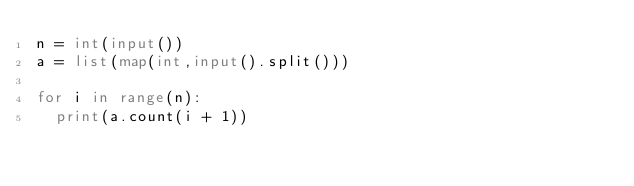<code> <loc_0><loc_0><loc_500><loc_500><_Python_>n = int(input())
a = list(map(int,input().split()))
 
for i in range(n):
	print(a.count(i + 1))</code> 